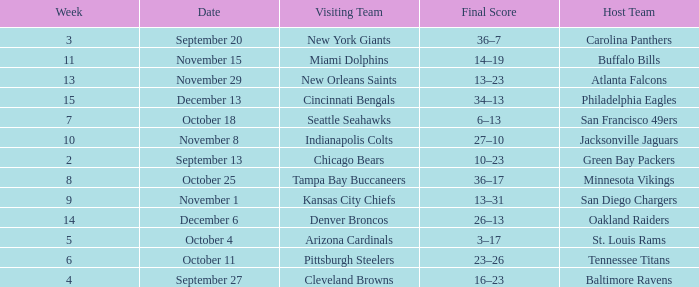Which week did the Baltimore Ravens play at home ? 4.0. 